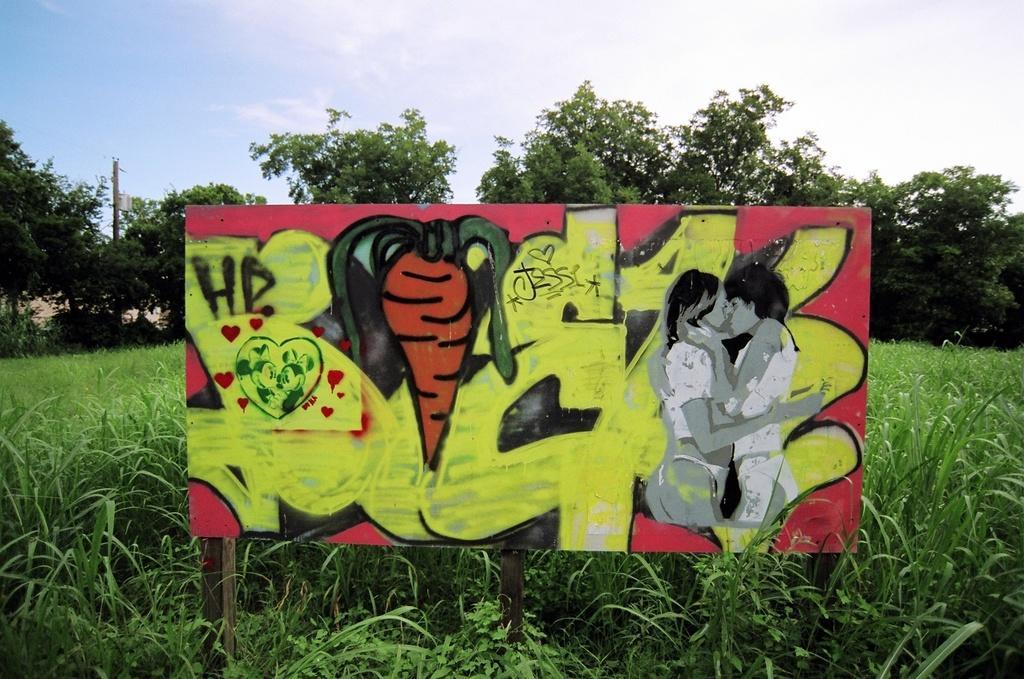In one or two sentences, can you explain what this image depicts? Here we can see a hoarding and plants. Background there are trees and pole. Sky is cloudy. 